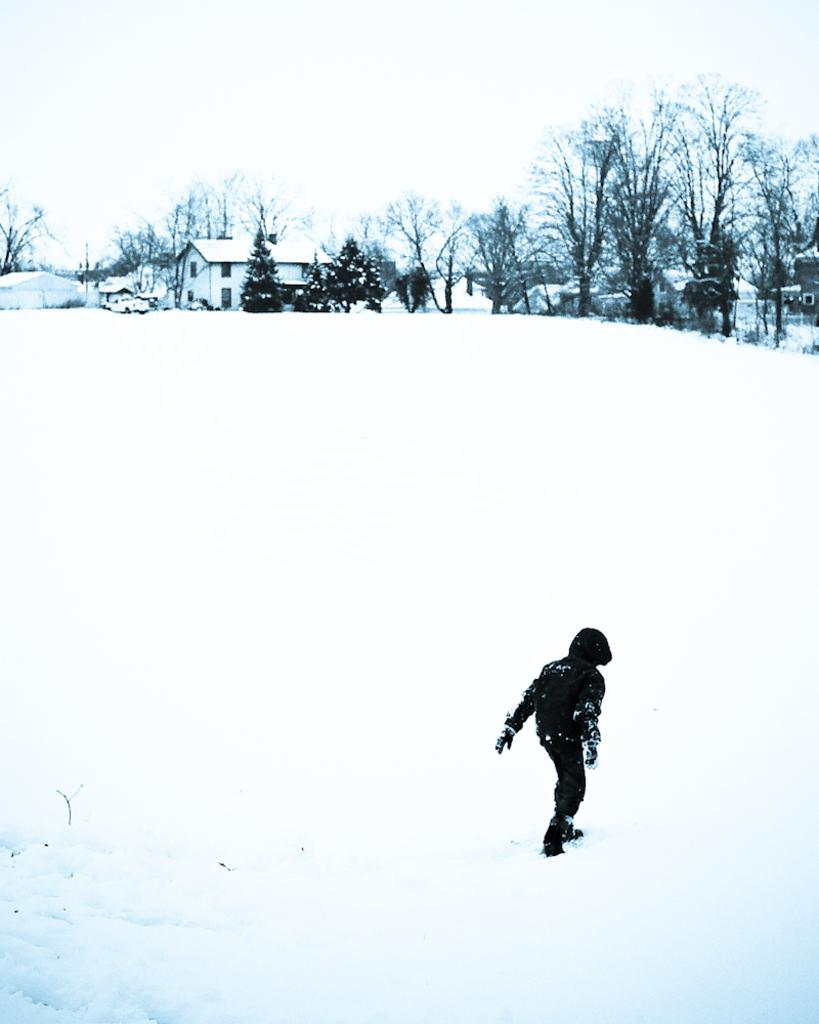What is the person in the image standing on? The person is standing on the ground covered with snow. What can be seen in the distance behind the person? There are houses and a group of trees visible in the background. How would you describe the sky in the image? The sky appears cloudy in the image. What type of property is being sold in the image? There is no indication of a property being sold in the image; it primarily features a person standing on snow-covered ground with houses and trees in the background. 